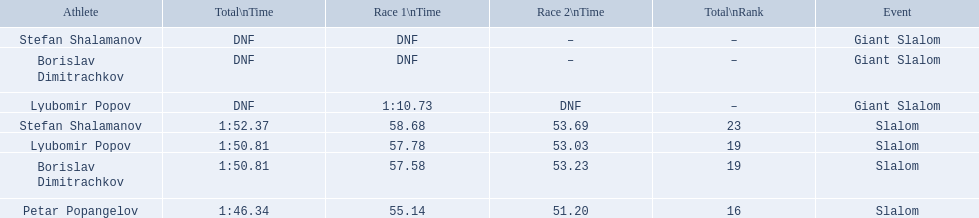What are all the competitions lyubomir popov competed in? Lyubomir Popov, Lyubomir Popov. Of those, which were giant slalom races? Giant Slalom. What was his time in race 1? 1:10.73. 